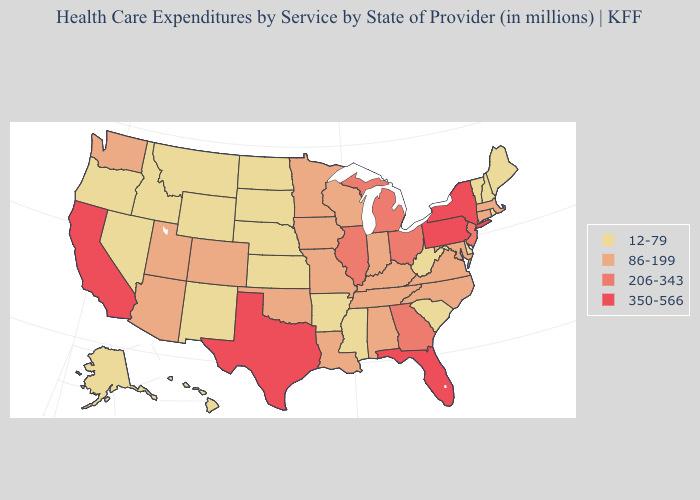Does Nevada have a lower value than Connecticut?
Quick response, please. Yes. What is the value of Louisiana?
Write a very short answer. 86-199. Which states have the lowest value in the USA?
Write a very short answer. Alaska, Arkansas, Delaware, Hawaii, Idaho, Kansas, Maine, Mississippi, Montana, Nebraska, Nevada, New Hampshire, New Mexico, North Dakota, Oregon, Rhode Island, South Carolina, South Dakota, Vermont, West Virginia, Wyoming. What is the lowest value in states that border Oklahoma?
Be succinct. 12-79. Which states have the lowest value in the Northeast?
Be succinct. Maine, New Hampshire, Rhode Island, Vermont. Name the states that have a value in the range 206-343?
Concise answer only. Georgia, Illinois, Michigan, New Jersey, Ohio. Which states have the lowest value in the South?
Keep it brief. Arkansas, Delaware, Mississippi, South Carolina, West Virginia. Among the states that border Vermont , which have the highest value?
Short answer required. New York. Does Illinois have the highest value in the MidWest?
Short answer required. Yes. What is the value of Minnesota?
Be succinct. 86-199. What is the value of Vermont?
Answer briefly. 12-79. What is the value of Wisconsin?
Keep it brief. 86-199. Which states have the highest value in the USA?
Be succinct. California, Florida, New York, Pennsylvania, Texas. Among the states that border Nevada , which have the highest value?
Write a very short answer. California. What is the lowest value in the Northeast?
Short answer required. 12-79. 